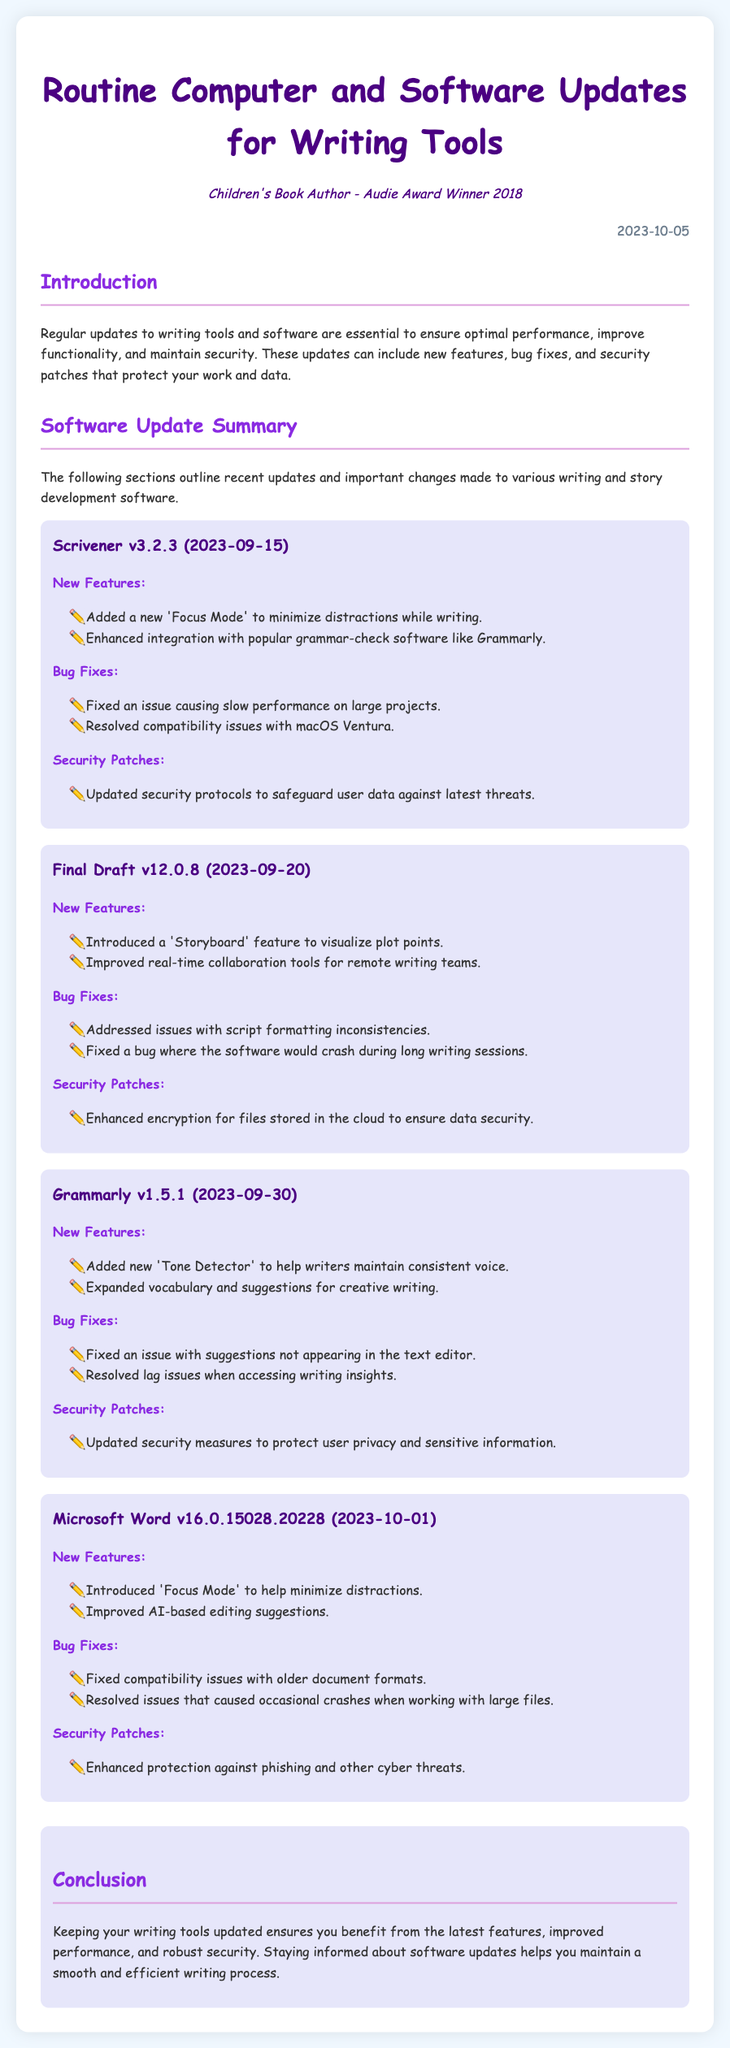What is the date of the latest maintenance log? The date is presented at the top of the document, indicating when the log was created.
Answer: 2023-10-05 What version of Scrivener is mentioned? This information is available in the section detailing software updates, specifying which version received updates.
Answer: v3.2.3 What new feature was added to Grammarly? The document lists the new features for each software, identifying what has been recently introduced.
Answer: Tone Detector How many bug fixes were listed for Final Draft? The number of bug fixes can be counted from the relevant section in the update for Final Draft.
Answer: 2 What type of mode was introduced in Microsoft Word? This is found in the section discussing new features for the Microsoft Word update.
Answer: Focus Mode Which software had enhanced encryption for cloud files? The section about security patches specifies which software received this particular update.
Answer: Final Draft What was a significant compatibility issue fixed in Scrivener? This can be inferred from the details provided in the bug fixes section for Scrivener.
Answer: macOS Ventura How many software updates were highlighted in the document? This is determined by counting the number of unique software updates provided in the log.
Answer: 4 